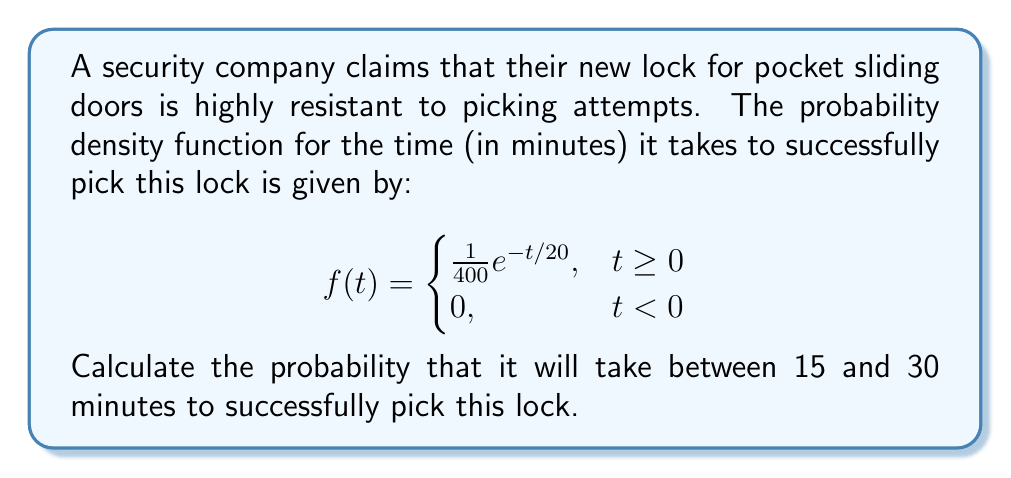Solve this math problem. To find the probability that it will take between 15 and 30 minutes to pick the lock, we need to integrate the probability density function over this interval:

$$P(15 \leq T \leq 30) = \int_{15}^{30} f(t) dt$$

Substituting the given function:

$$P(15 \leq T \leq 30) = \int_{15}^{30} \frac{1}{400}e^{-t/20} dt$$

To solve this integral, we'll use the substitution method:

Let $u = -t/20$, then $du = -\frac{1}{20}dt$ and $dt = -20du$

When $t = 15$, $u = -15/20 = -3/4$
When $t = 30$, $u = -30/20 = -3/2$

Rewriting the integral:

$$P(15 \leq T \leq 30) = \int_{-3/2}^{-3/4} \frac{1}{400}e^u (-20du)$$

$$= -\frac{1}{20} \int_{-3/2}^{-3/4} e^u du$$

$$= -\frac{1}{20} [e^u]_{-3/2}^{-3/4}$$

$$= -\frac{1}{20} (e^{-3/4} - e^{-3/2})$$

$$= \frac{1}{20} (e^{-3/2} - e^{-3/4})$$

$$= \frac{1}{20} (e^{-1.5} - e^{-0.75})$$

Using a calculator to evaluate:

$$= \frac{1}{20} (0.2231 - 0.4724)$$

$$= -0.01246$$

Therefore, the probability is approximately 0.01246 or 1.246%.
Answer: 0.01246 